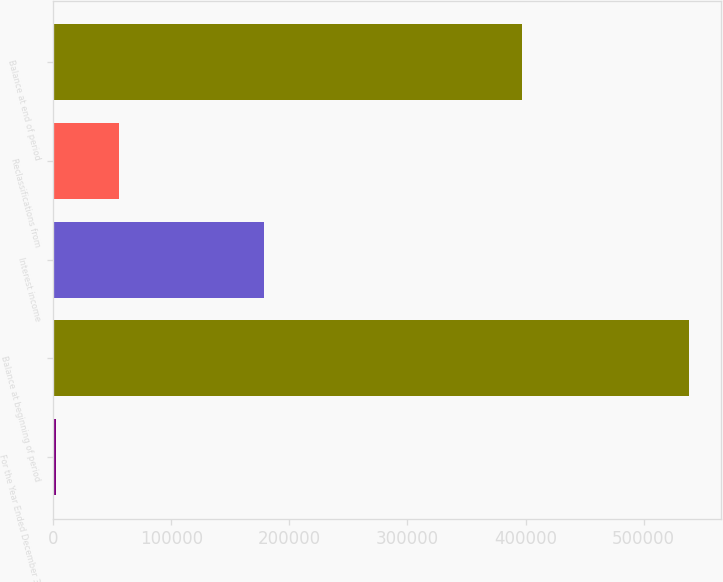<chart> <loc_0><loc_0><loc_500><loc_500><bar_chart><fcel>For the Year Ended December 31<fcel>Balance at beginning of period<fcel>Interest income<fcel>Reclassifications from<fcel>Balance at end of period<nl><fcel>2014<fcel>538633<fcel>178670<fcel>55675.9<fcel>397379<nl></chart> 